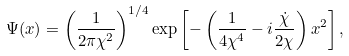<formula> <loc_0><loc_0><loc_500><loc_500>\Psi ( x ) = \left ( \frac { 1 } { 2 \pi \chi ^ { 2 } } \right ) ^ { 1 / 4 } \exp \left [ - \left ( \frac { 1 } { 4 \chi ^ { 4 } } - i \frac { \dot { \chi } } { 2 \chi } \right ) x ^ { 2 } \right ] ,</formula> 